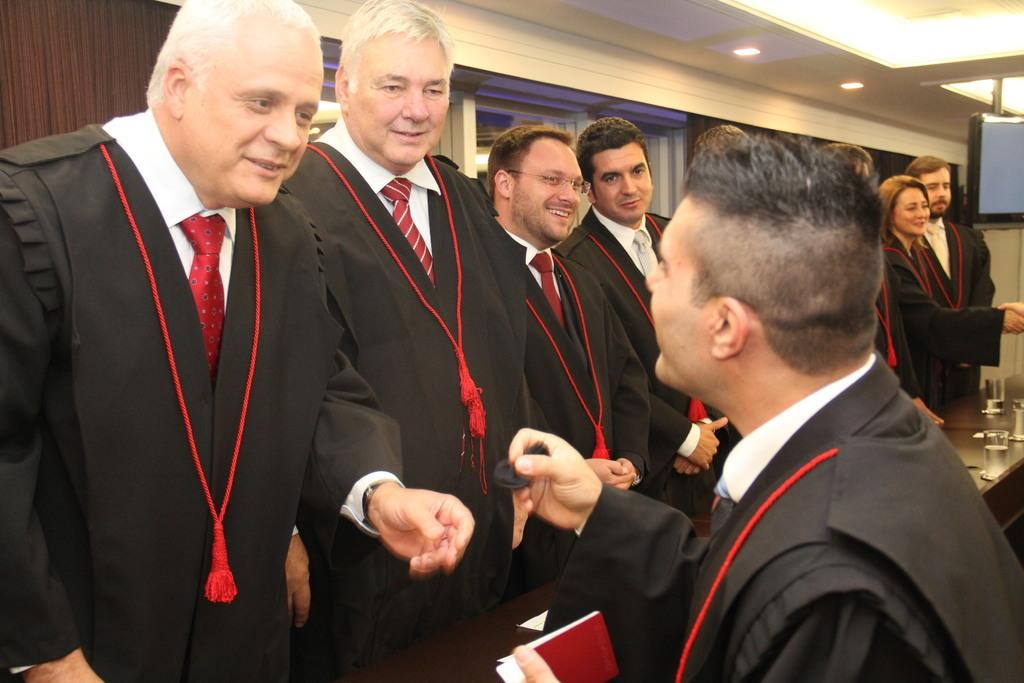How many people are in the image? There is a group of persons in the image. What are the persons in the image doing? The persons are standing at a table. What can be seen in the glasses on the table? There is water in glasses on the table. What is visible in the background of the image? There is a wall, lights, a television, and windows in the background of the image. How many legs can be seen on the chickens in the image? There are no chickens present in the image. What type of camp is set up in the background of the image? There is no camp present in the image; it features a group of persons standing at a table with water in glasses, and a background with a wall, lights, a television, and windows. 